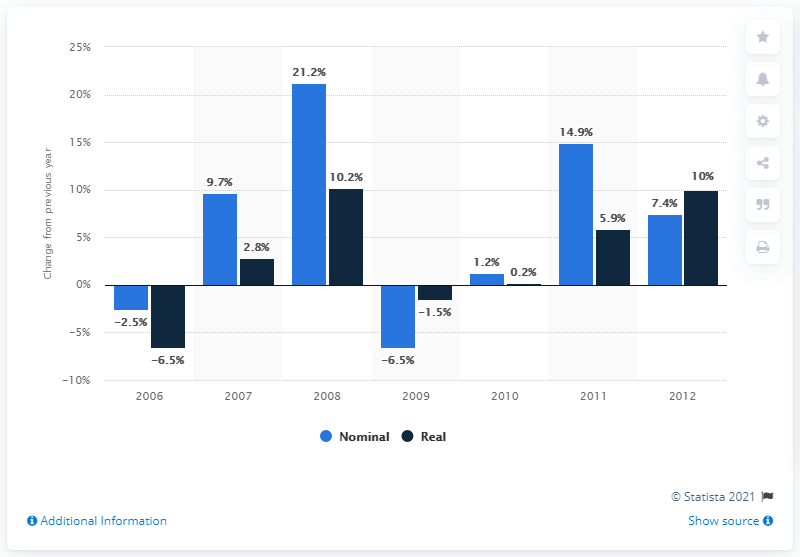Draw attention to some important aspects in this diagram. The global crop protection market increased by 21.2% in 2008. 